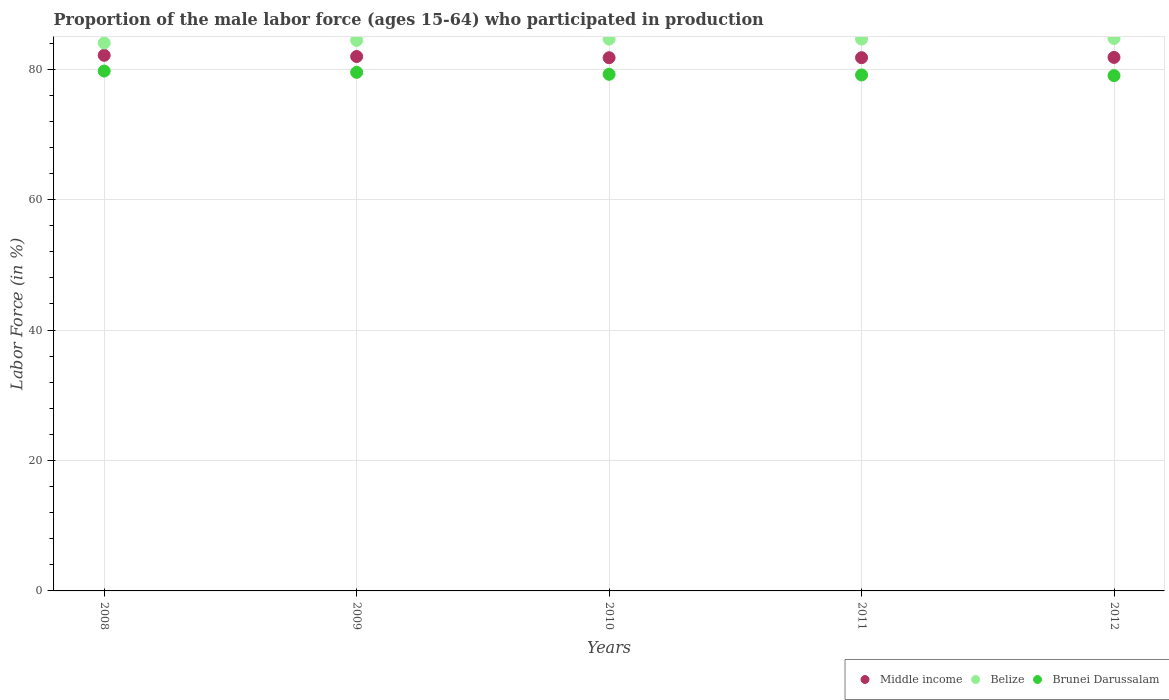What is the proportion of the male labor force who participated in production in Belize in 2011?
Give a very brief answer. 84.6. Across all years, what is the maximum proportion of the male labor force who participated in production in Belize?
Your response must be concise. 84.7. Across all years, what is the minimum proportion of the male labor force who participated in production in Brunei Darussalam?
Offer a terse response. 79. In which year was the proportion of the male labor force who participated in production in Middle income maximum?
Ensure brevity in your answer.  2008. What is the total proportion of the male labor force who participated in production in Brunei Darussalam in the graph?
Offer a very short reply. 396.5. What is the difference between the proportion of the male labor force who participated in production in Middle income in 2008 and that in 2010?
Your answer should be very brief. 0.37. What is the difference between the proportion of the male labor force who participated in production in Belize in 2011 and the proportion of the male labor force who participated in production in Brunei Darussalam in 2009?
Provide a short and direct response. 5.1. What is the average proportion of the male labor force who participated in production in Middle income per year?
Your response must be concise. 81.87. In the year 2012, what is the difference between the proportion of the male labor force who participated in production in Middle income and proportion of the male labor force who participated in production in Brunei Darussalam?
Provide a succinct answer. 2.79. What is the ratio of the proportion of the male labor force who participated in production in Belize in 2008 to that in 2012?
Offer a very short reply. 0.99. Is the proportion of the male labor force who participated in production in Brunei Darussalam in 2009 less than that in 2010?
Make the answer very short. No. What is the difference between the highest and the second highest proportion of the male labor force who participated in production in Middle income?
Offer a terse response. 0.18. What is the difference between the highest and the lowest proportion of the male labor force who participated in production in Belize?
Give a very brief answer. 0.7. Is it the case that in every year, the sum of the proportion of the male labor force who participated in production in Brunei Darussalam and proportion of the male labor force who participated in production in Middle income  is greater than the proportion of the male labor force who participated in production in Belize?
Offer a very short reply. Yes. Does the proportion of the male labor force who participated in production in Belize monotonically increase over the years?
Your answer should be very brief. No. How many dotlines are there?
Make the answer very short. 3. Does the graph contain grids?
Your answer should be very brief. Yes. Where does the legend appear in the graph?
Ensure brevity in your answer.  Bottom right. What is the title of the graph?
Your response must be concise. Proportion of the male labor force (ages 15-64) who participated in production. What is the label or title of the X-axis?
Offer a very short reply. Years. What is the label or title of the Y-axis?
Your answer should be very brief. Labor Force (in %). What is the Labor Force (in %) in Middle income in 2008?
Your answer should be very brief. 82.11. What is the Labor Force (in %) in Brunei Darussalam in 2008?
Ensure brevity in your answer.  79.7. What is the Labor Force (in %) in Middle income in 2009?
Keep it short and to the point. 81.93. What is the Labor Force (in %) of Belize in 2009?
Provide a short and direct response. 84.4. What is the Labor Force (in %) in Brunei Darussalam in 2009?
Give a very brief answer. 79.5. What is the Labor Force (in %) in Middle income in 2010?
Provide a short and direct response. 81.74. What is the Labor Force (in %) in Belize in 2010?
Offer a very short reply. 84.6. What is the Labor Force (in %) in Brunei Darussalam in 2010?
Your response must be concise. 79.2. What is the Labor Force (in %) of Middle income in 2011?
Offer a terse response. 81.75. What is the Labor Force (in %) of Belize in 2011?
Your answer should be compact. 84.6. What is the Labor Force (in %) in Brunei Darussalam in 2011?
Make the answer very short. 79.1. What is the Labor Force (in %) in Middle income in 2012?
Offer a very short reply. 81.79. What is the Labor Force (in %) in Belize in 2012?
Offer a very short reply. 84.7. What is the Labor Force (in %) of Brunei Darussalam in 2012?
Keep it short and to the point. 79. Across all years, what is the maximum Labor Force (in %) in Middle income?
Provide a short and direct response. 82.11. Across all years, what is the maximum Labor Force (in %) of Belize?
Keep it short and to the point. 84.7. Across all years, what is the maximum Labor Force (in %) in Brunei Darussalam?
Your answer should be very brief. 79.7. Across all years, what is the minimum Labor Force (in %) in Middle income?
Keep it short and to the point. 81.74. Across all years, what is the minimum Labor Force (in %) in Belize?
Provide a succinct answer. 84. Across all years, what is the minimum Labor Force (in %) of Brunei Darussalam?
Ensure brevity in your answer.  79. What is the total Labor Force (in %) of Middle income in the graph?
Your response must be concise. 409.33. What is the total Labor Force (in %) of Belize in the graph?
Your answer should be compact. 422.3. What is the total Labor Force (in %) in Brunei Darussalam in the graph?
Your response must be concise. 396.5. What is the difference between the Labor Force (in %) of Middle income in 2008 and that in 2009?
Offer a very short reply. 0.18. What is the difference between the Labor Force (in %) of Belize in 2008 and that in 2009?
Ensure brevity in your answer.  -0.4. What is the difference between the Labor Force (in %) of Middle income in 2008 and that in 2010?
Your answer should be compact. 0.37. What is the difference between the Labor Force (in %) of Belize in 2008 and that in 2010?
Make the answer very short. -0.6. What is the difference between the Labor Force (in %) of Middle income in 2008 and that in 2011?
Offer a very short reply. 0.36. What is the difference between the Labor Force (in %) of Brunei Darussalam in 2008 and that in 2011?
Give a very brief answer. 0.6. What is the difference between the Labor Force (in %) in Middle income in 2008 and that in 2012?
Provide a short and direct response. 0.32. What is the difference between the Labor Force (in %) in Belize in 2008 and that in 2012?
Provide a succinct answer. -0.7. What is the difference between the Labor Force (in %) in Brunei Darussalam in 2008 and that in 2012?
Provide a short and direct response. 0.7. What is the difference between the Labor Force (in %) of Middle income in 2009 and that in 2010?
Make the answer very short. 0.19. What is the difference between the Labor Force (in %) of Middle income in 2009 and that in 2011?
Ensure brevity in your answer.  0.18. What is the difference between the Labor Force (in %) in Belize in 2009 and that in 2011?
Make the answer very short. -0.2. What is the difference between the Labor Force (in %) in Brunei Darussalam in 2009 and that in 2011?
Keep it short and to the point. 0.4. What is the difference between the Labor Force (in %) of Middle income in 2009 and that in 2012?
Your answer should be very brief. 0.14. What is the difference between the Labor Force (in %) in Belize in 2009 and that in 2012?
Offer a very short reply. -0.3. What is the difference between the Labor Force (in %) of Middle income in 2010 and that in 2011?
Provide a succinct answer. -0. What is the difference between the Labor Force (in %) in Belize in 2010 and that in 2011?
Provide a short and direct response. 0. What is the difference between the Labor Force (in %) in Brunei Darussalam in 2010 and that in 2011?
Your response must be concise. 0.1. What is the difference between the Labor Force (in %) in Middle income in 2010 and that in 2012?
Make the answer very short. -0.05. What is the difference between the Labor Force (in %) of Belize in 2010 and that in 2012?
Your answer should be very brief. -0.1. What is the difference between the Labor Force (in %) of Brunei Darussalam in 2010 and that in 2012?
Your answer should be very brief. 0.2. What is the difference between the Labor Force (in %) of Middle income in 2011 and that in 2012?
Your answer should be compact. -0.04. What is the difference between the Labor Force (in %) in Belize in 2011 and that in 2012?
Provide a short and direct response. -0.1. What is the difference between the Labor Force (in %) of Brunei Darussalam in 2011 and that in 2012?
Offer a very short reply. 0.1. What is the difference between the Labor Force (in %) in Middle income in 2008 and the Labor Force (in %) in Belize in 2009?
Provide a short and direct response. -2.29. What is the difference between the Labor Force (in %) in Middle income in 2008 and the Labor Force (in %) in Brunei Darussalam in 2009?
Provide a succinct answer. 2.61. What is the difference between the Labor Force (in %) in Belize in 2008 and the Labor Force (in %) in Brunei Darussalam in 2009?
Keep it short and to the point. 4.5. What is the difference between the Labor Force (in %) of Middle income in 2008 and the Labor Force (in %) of Belize in 2010?
Provide a short and direct response. -2.49. What is the difference between the Labor Force (in %) of Middle income in 2008 and the Labor Force (in %) of Brunei Darussalam in 2010?
Keep it short and to the point. 2.91. What is the difference between the Labor Force (in %) in Middle income in 2008 and the Labor Force (in %) in Belize in 2011?
Ensure brevity in your answer.  -2.49. What is the difference between the Labor Force (in %) of Middle income in 2008 and the Labor Force (in %) of Brunei Darussalam in 2011?
Your answer should be very brief. 3.01. What is the difference between the Labor Force (in %) of Belize in 2008 and the Labor Force (in %) of Brunei Darussalam in 2011?
Keep it short and to the point. 4.9. What is the difference between the Labor Force (in %) of Middle income in 2008 and the Labor Force (in %) of Belize in 2012?
Provide a short and direct response. -2.59. What is the difference between the Labor Force (in %) of Middle income in 2008 and the Labor Force (in %) of Brunei Darussalam in 2012?
Provide a succinct answer. 3.11. What is the difference between the Labor Force (in %) of Middle income in 2009 and the Labor Force (in %) of Belize in 2010?
Provide a succinct answer. -2.67. What is the difference between the Labor Force (in %) of Middle income in 2009 and the Labor Force (in %) of Brunei Darussalam in 2010?
Give a very brief answer. 2.73. What is the difference between the Labor Force (in %) in Belize in 2009 and the Labor Force (in %) in Brunei Darussalam in 2010?
Ensure brevity in your answer.  5.2. What is the difference between the Labor Force (in %) of Middle income in 2009 and the Labor Force (in %) of Belize in 2011?
Offer a terse response. -2.67. What is the difference between the Labor Force (in %) of Middle income in 2009 and the Labor Force (in %) of Brunei Darussalam in 2011?
Offer a terse response. 2.83. What is the difference between the Labor Force (in %) of Middle income in 2009 and the Labor Force (in %) of Belize in 2012?
Your answer should be compact. -2.77. What is the difference between the Labor Force (in %) in Middle income in 2009 and the Labor Force (in %) in Brunei Darussalam in 2012?
Make the answer very short. 2.93. What is the difference between the Labor Force (in %) of Belize in 2009 and the Labor Force (in %) of Brunei Darussalam in 2012?
Your response must be concise. 5.4. What is the difference between the Labor Force (in %) of Middle income in 2010 and the Labor Force (in %) of Belize in 2011?
Offer a terse response. -2.86. What is the difference between the Labor Force (in %) in Middle income in 2010 and the Labor Force (in %) in Brunei Darussalam in 2011?
Keep it short and to the point. 2.64. What is the difference between the Labor Force (in %) of Middle income in 2010 and the Labor Force (in %) of Belize in 2012?
Make the answer very short. -2.96. What is the difference between the Labor Force (in %) in Middle income in 2010 and the Labor Force (in %) in Brunei Darussalam in 2012?
Provide a short and direct response. 2.74. What is the difference between the Labor Force (in %) of Middle income in 2011 and the Labor Force (in %) of Belize in 2012?
Ensure brevity in your answer.  -2.95. What is the difference between the Labor Force (in %) in Middle income in 2011 and the Labor Force (in %) in Brunei Darussalam in 2012?
Offer a very short reply. 2.75. What is the average Labor Force (in %) in Middle income per year?
Provide a succinct answer. 81.86. What is the average Labor Force (in %) in Belize per year?
Provide a succinct answer. 84.46. What is the average Labor Force (in %) of Brunei Darussalam per year?
Your answer should be compact. 79.3. In the year 2008, what is the difference between the Labor Force (in %) in Middle income and Labor Force (in %) in Belize?
Give a very brief answer. -1.89. In the year 2008, what is the difference between the Labor Force (in %) of Middle income and Labor Force (in %) of Brunei Darussalam?
Your response must be concise. 2.41. In the year 2008, what is the difference between the Labor Force (in %) of Belize and Labor Force (in %) of Brunei Darussalam?
Keep it short and to the point. 4.3. In the year 2009, what is the difference between the Labor Force (in %) of Middle income and Labor Force (in %) of Belize?
Keep it short and to the point. -2.47. In the year 2009, what is the difference between the Labor Force (in %) in Middle income and Labor Force (in %) in Brunei Darussalam?
Make the answer very short. 2.43. In the year 2010, what is the difference between the Labor Force (in %) in Middle income and Labor Force (in %) in Belize?
Provide a short and direct response. -2.86. In the year 2010, what is the difference between the Labor Force (in %) of Middle income and Labor Force (in %) of Brunei Darussalam?
Your answer should be very brief. 2.54. In the year 2010, what is the difference between the Labor Force (in %) in Belize and Labor Force (in %) in Brunei Darussalam?
Provide a short and direct response. 5.4. In the year 2011, what is the difference between the Labor Force (in %) of Middle income and Labor Force (in %) of Belize?
Keep it short and to the point. -2.85. In the year 2011, what is the difference between the Labor Force (in %) of Middle income and Labor Force (in %) of Brunei Darussalam?
Give a very brief answer. 2.65. In the year 2012, what is the difference between the Labor Force (in %) in Middle income and Labor Force (in %) in Belize?
Make the answer very short. -2.91. In the year 2012, what is the difference between the Labor Force (in %) of Middle income and Labor Force (in %) of Brunei Darussalam?
Your answer should be compact. 2.79. What is the ratio of the Labor Force (in %) of Middle income in 2008 to that in 2009?
Give a very brief answer. 1. What is the ratio of the Labor Force (in %) of Belize in 2008 to that in 2009?
Ensure brevity in your answer.  1. What is the ratio of the Labor Force (in %) of Brunei Darussalam in 2008 to that in 2009?
Your answer should be compact. 1. What is the ratio of the Labor Force (in %) of Middle income in 2008 to that in 2010?
Ensure brevity in your answer.  1. What is the ratio of the Labor Force (in %) in Belize in 2008 to that in 2010?
Offer a terse response. 0.99. What is the ratio of the Labor Force (in %) in Brunei Darussalam in 2008 to that in 2010?
Give a very brief answer. 1.01. What is the ratio of the Labor Force (in %) in Middle income in 2008 to that in 2011?
Offer a terse response. 1. What is the ratio of the Labor Force (in %) in Brunei Darussalam in 2008 to that in 2011?
Your response must be concise. 1.01. What is the ratio of the Labor Force (in %) in Middle income in 2008 to that in 2012?
Make the answer very short. 1. What is the ratio of the Labor Force (in %) of Brunei Darussalam in 2008 to that in 2012?
Your response must be concise. 1.01. What is the ratio of the Labor Force (in %) of Middle income in 2009 to that in 2010?
Your answer should be very brief. 1. What is the ratio of the Labor Force (in %) in Belize in 2009 to that in 2010?
Your response must be concise. 1. What is the ratio of the Labor Force (in %) in Brunei Darussalam in 2009 to that in 2010?
Ensure brevity in your answer.  1. What is the ratio of the Labor Force (in %) of Middle income in 2009 to that in 2011?
Offer a very short reply. 1. What is the ratio of the Labor Force (in %) of Belize in 2009 to that in 2011?
Keep it short and to the point. 1. What is the ratio of the Labor Force (in %) in Brunei Darussalam in 2009 to that in 2011?
Give a very brief answer. 1.01. What is the ratio of the Labor Force (in %) in Belize in 2009 to that in 2012?
Ensure brevity in your answer.  1. What is the ratio of the Labor Force (in %) in Brunei Darussalam in 2009 to that in 2012?
Ensure brevity in your answer.  1.01. What is the ratio of the Labor Force (in %) of Middle income in 2010 to that in 2012?
Provide a short and direct response. 1. What is the ratio of the Labor Force (in %) of Brunei Darussalam in 2010 to that in 2012?
Give a very brief answer. 1. What is the ratio of the Labor Force (in %) of Middle income in 2011 to that in 2012?
Make the answer very short. 1. What is the difference between the highest and the second highest Labor Force (in %) of Middle income?
Make the answer very short. 0.18. What is the difference between the highest and the second highest Labor Force (in %) in Brunei Darussalam?
Your answer should be very brief. 0.2. What is the difference between the highest and the lowest Labor Force (in %) of Middle income?
Make the answer very short. 0.37. What is the difference between the highest and the lowest Labor Force (in %) in Belize?
Offer a terse response. 0.7. 